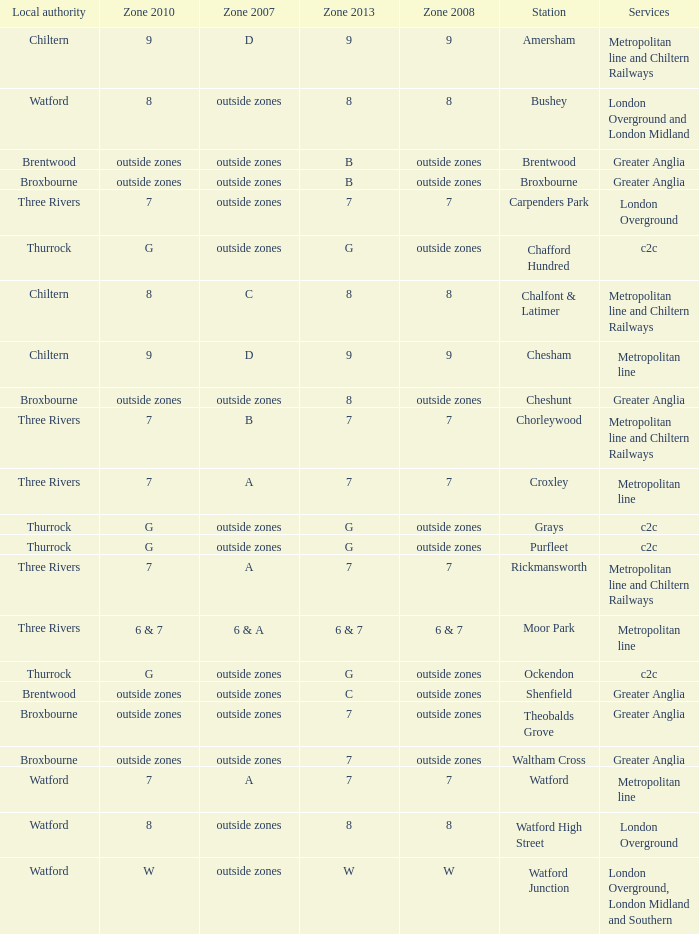Which Station has a Zone 2010 of 7? Carpenders Park, Chorleywood, Croxley, Rickmansworth, Watford. 